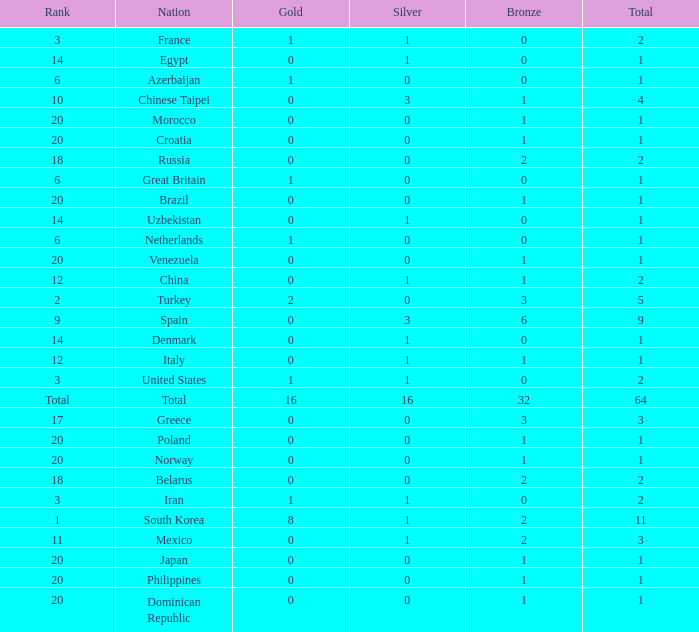What is the average number of bronze medals of the Philippines, which has more than 0 gold? None. 